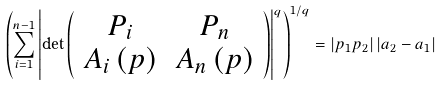<formula> <loc_0><loc_0><loc_500><loc_500>\left ( \sum _ { i = 1 } ^ { n - 1 } \left | \det \left ( \begin{array} { c c } P _ { i } & P _ { n } \\ A _ { i } \left ( p \right ) & A _ { n } \left ( p \right ) \end{array} \right ) \right | ^ { q } \right ) ^ { 1 / q } = \left | p _ { 1 } p _ { 2 } \right | \left | a _ { 2 } - a _ { 1 } \right |</formula> 